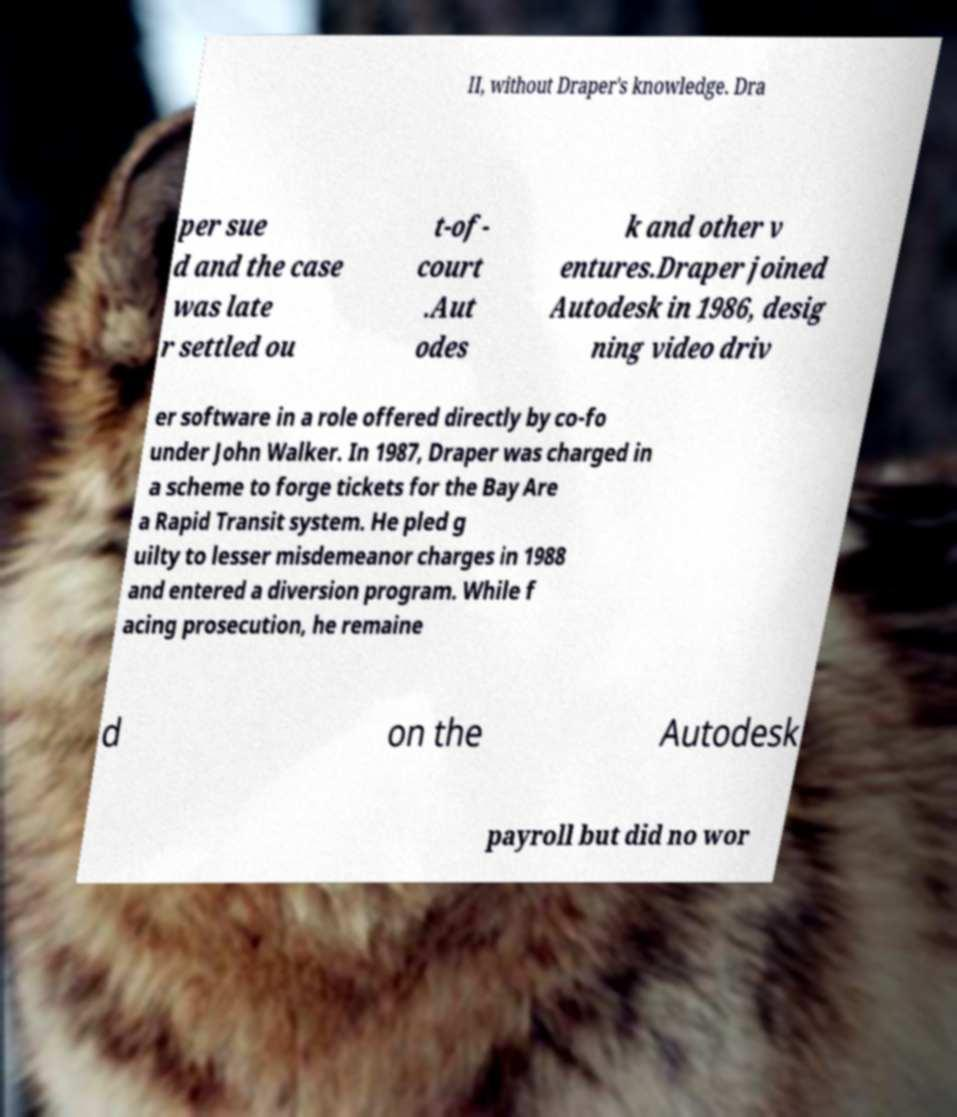There's text embedded in this image that I need extracted. Can you transcribe it verbatim? II, without Draper's knowledge. Dra per sue d and the case was late r settled ou t-of- court .Aut odes k and other v entures.Draper joined Autodesk in 1986, desig ning video driv er software in a role offered directly by co-fo under John Walker. In 1987, Draper was charged in a scheme to forge tickets for the Bay Are a Rapid Transit system. He pled g uilty to lesser misdemeanor charges in 1988 and entered a diversion program. While f acing prosecution, he remaine d on the Autodesk payroll but did no wor 